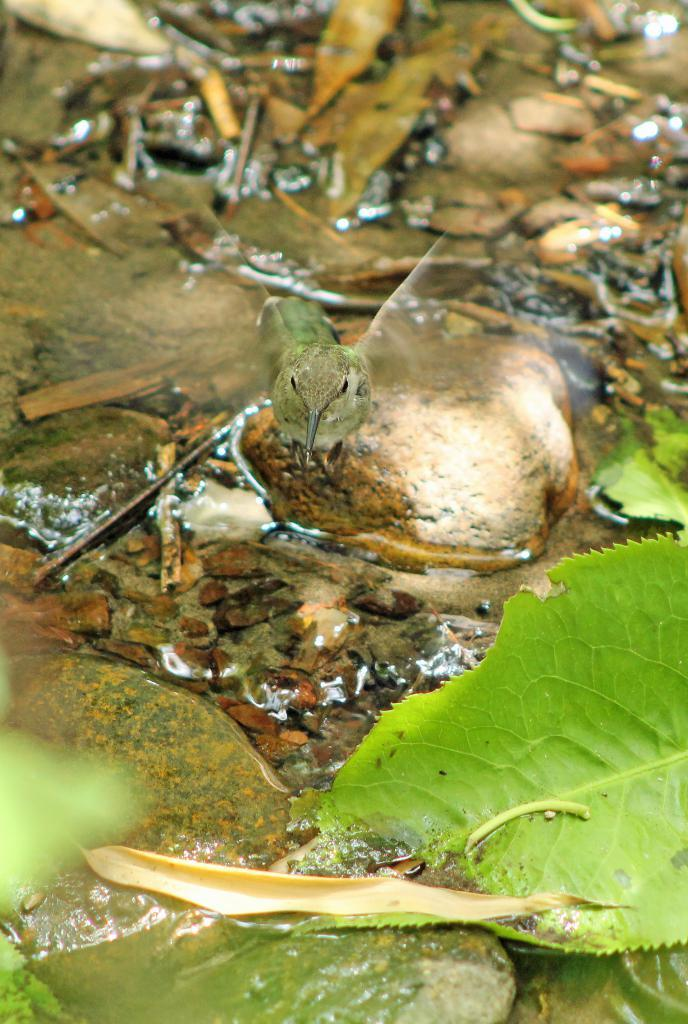What type of animal can be seen in the image? There is a bird in the image. Where is the bird located? The bird is on a stone in the image. What else can be seen in the image besides the bird? There is water visible in the image, as well as stones and leaves on the ground. What type of juice can be seen flowing from the drain in the image? There is no drain or juice present in the image. 